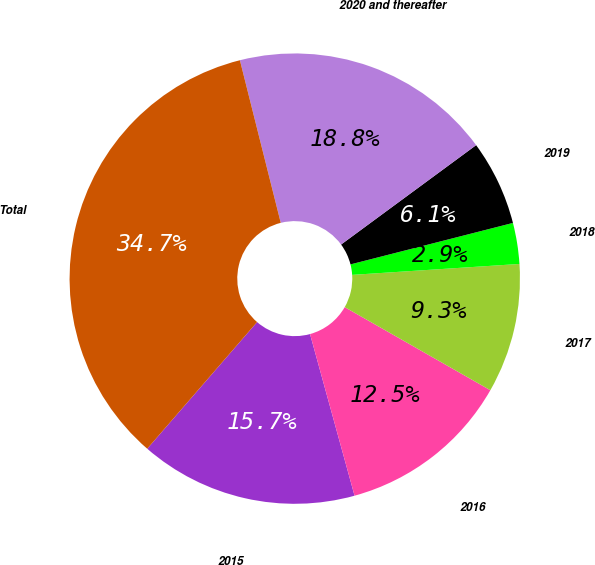Convert chart to OTSL. <chart><loc_0><loc_0><loc_500><loc_500><pie_chart><fcel>2015<fcel>2016<fcel>2017<fcel>2018<fcel>2019<fcel>2020 and thereafter<fcel>Total<nl><fcel>15.65%<fcel>12.47%<fcel>9.29%<fcel>2.94%<fcel>6.12%<fcel>18.82%<fcel>34.71%<nl></chart> 